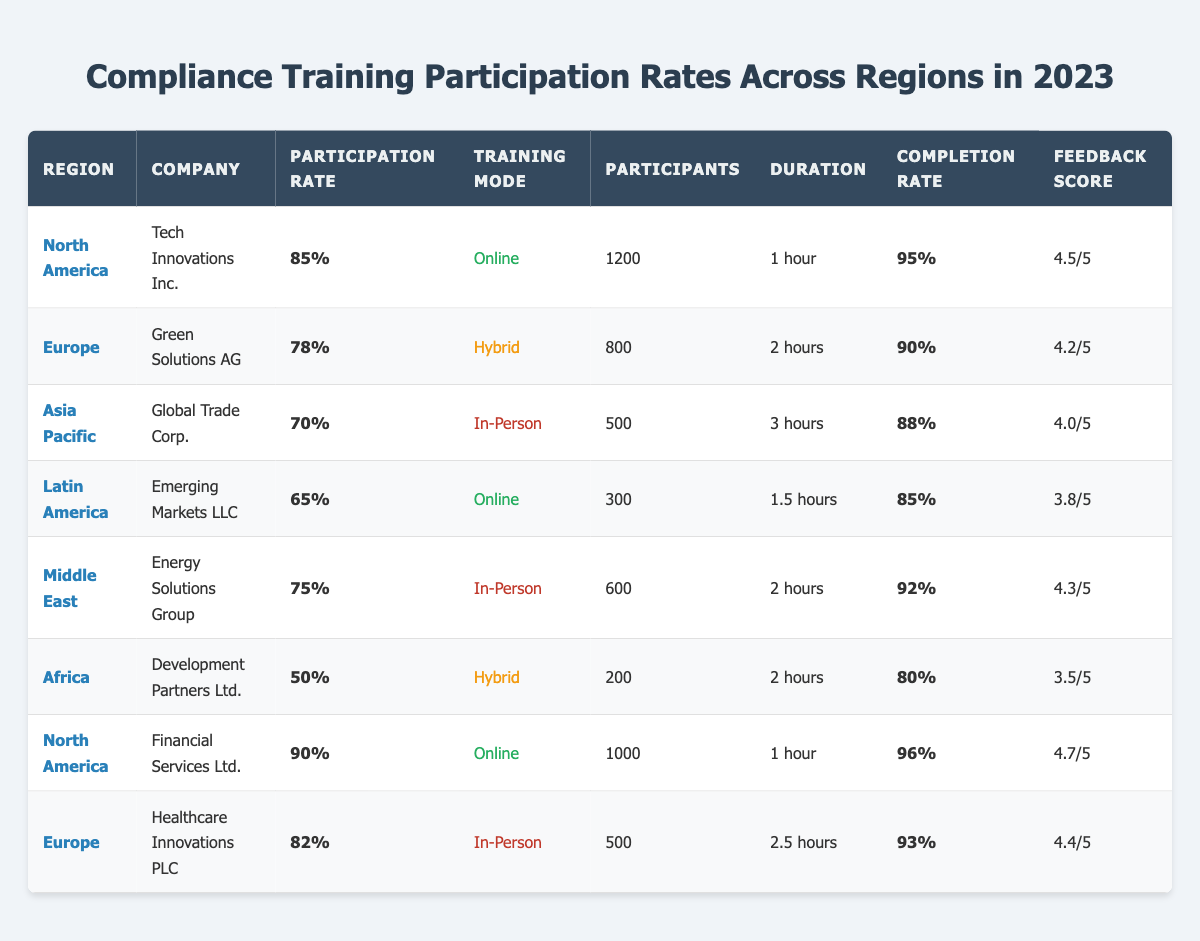What is the participation rate for "Tech Innovations Inc." in North America? According to the table, the participation rate for "Tech Innovations Inc." based in North America is listed as 85%.
Answer: 85% Which region has the highest training completion rate? By reviewing the "Completion Rate" column, North America (Financial Services Ltd.) has the highest completion rate at 96%.
Answer: 96% How many participants were trained by "Healthcare Innovations PLC" in Europe? The "Participants" column shows that "Healthcare Innovations PLC" had 500 participants in Europe.
Answer: 500 What is the average participation rate across all regions? The participation rates are 85%, 78%, 70%, 65%, 75%, 50%, 90%, and 82%. Summing these gives 85 + 78 + 70 + 65 + 75 + 50 + 90 + 82 =  695. There are 8 regions, so the average is 695/8 = 86.875%.
Answer: 86.88% Is the feedback score for "Emerging Markets LLC" higher than 4.0? The feedback score for "Emerging Markets LLC" is 3.8/5, which is less than 4.0.
Answer: No Which training mode has the lowest average participation rate? The average participation rates are 85% (online), 80% (in-person), and 65% (hybrid). Therefore, hybrid training mode has the lowest average participation rate at 65%.
Answer: Hybrid Which region had the least number of participants trained? "Development Partners Ltd." in Africa had the least number of participants with a count of 200.
Answer: 200 What is the total number of participants trained in North America? North America has two companies with 1200 (Tech Innovations Inc.) and 1000 (Financial Services Ltd.) participants. Totaling these gives 1200 + 1000 = 2200.
Answer: 2200 Which company in Europe had a higher feedback score: "Green Solutions AG" or "Healthcare Innovations PLC"? "Green Solutions AG" has a feedback score of 4.2, while "Healthcare Innovations PLC" has a score of 4.4. Comparing these, 4.4 is higher than 4.2.
Answer: Healthcare Innovations PLC Is the participation rate larger than 75% for "Global Trade Corp." in Asia Pacific? The participation rate of "Global Trade Corp." is 70%, which is less than 75%.
Answer: No 